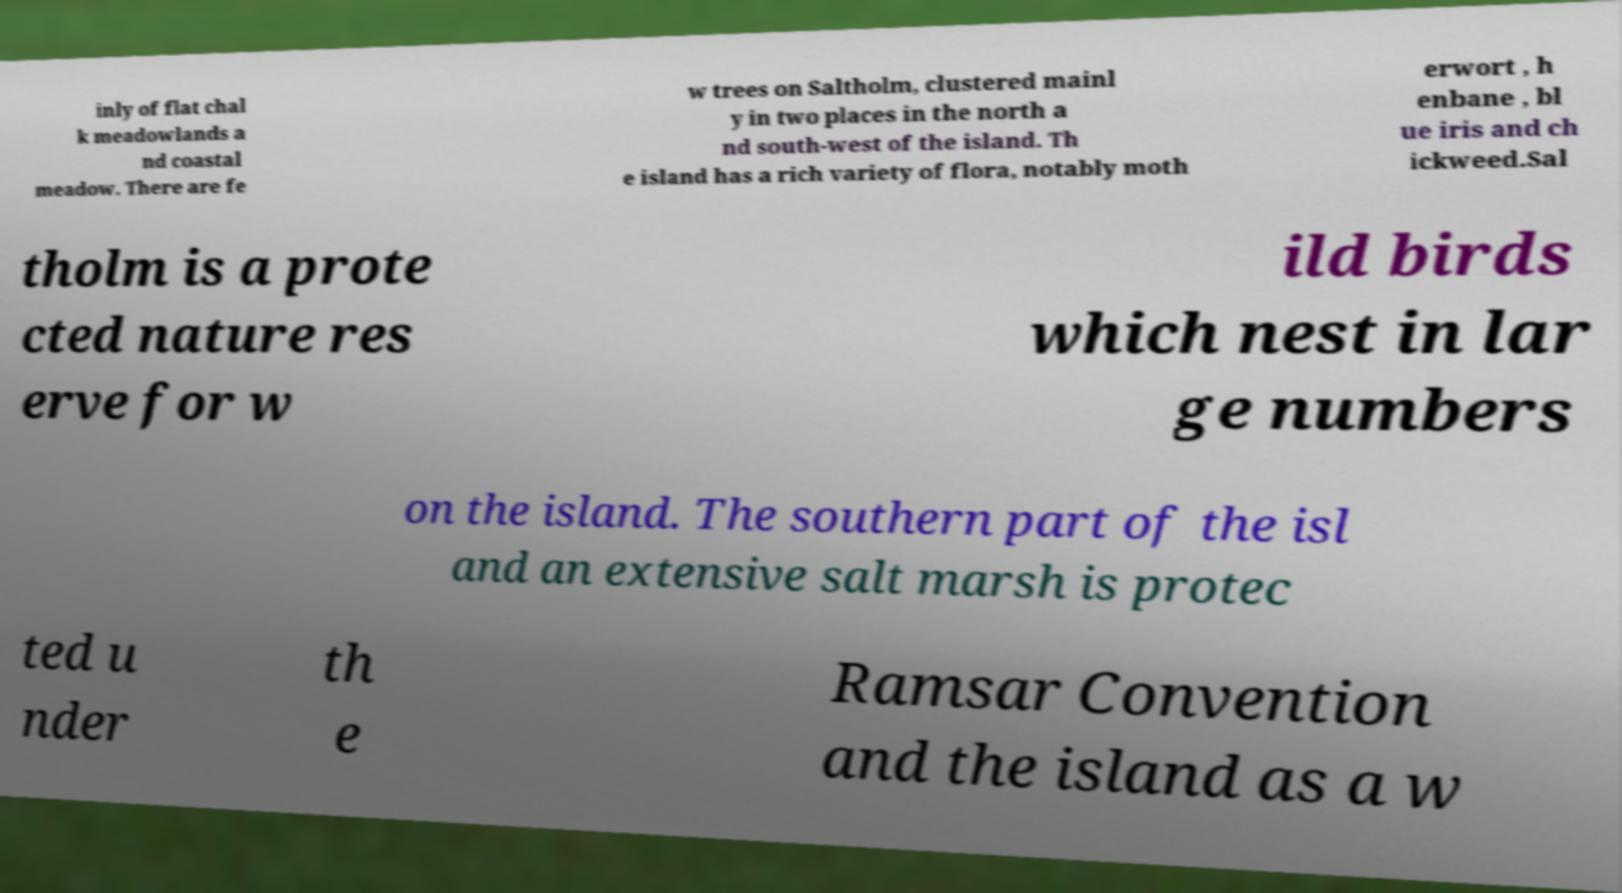There's text embedded in this image that I need extracted. Can you transcribe it verbatim? inly of flat chal k meadowlands a nd coastal meadow. There are fe w trees on Saltholm, clustered mainl y in two places in the north a nd south-west of the island. Th e island has a rich variety of flora, notably moth erwort , h enbane , bl ue iris and ch ickweed.Sal tholm is a prote cted nature res erve for w ild birds which nest in lar ge numbers on the island. The southern part of the isl and an extensive salt marsh is protec ted u nder th e Ramsar Convention and the island as a w 